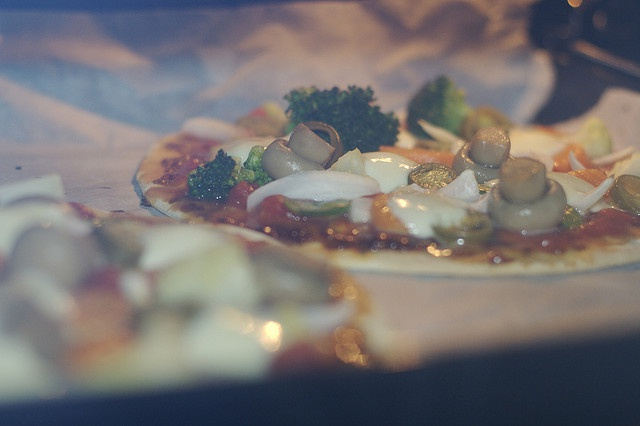Describe the objects in this image and their specific colors. I can see pizza in blue, gray, darkgray, and tan tones, pizza in blue, darkgray, and gray tones, broccoli in blue and gray tones, broccoli in blue and gray tones, and broccoli in blue, gray, and darkgray tones in this image. 